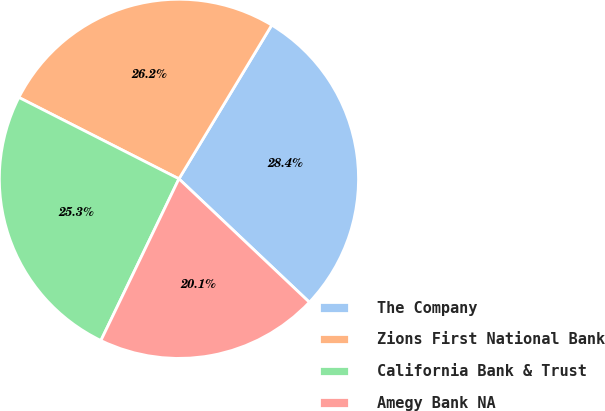Convert chart. <chart><loc_0><loc_0><loc_500><loc_500><pie_chart><fcel>The Company<fcel>Zions First National Bank<fcel>California Bank & Trust<fcel>Amegy Bank NA<nl><fcel>28.42%<fcel>26.16%<fcel>25.33%<fcel>20.1%<nl></chart> 